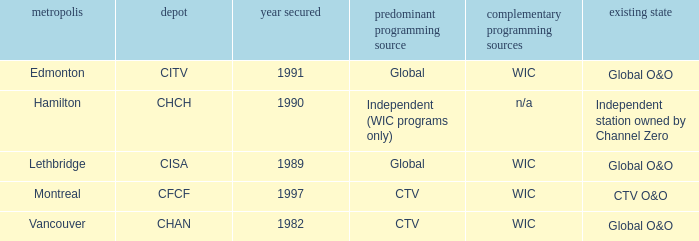Where is citv located Edmonton. 